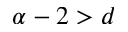Convert formula to latex. <formula><loc_0><loc_0><loc_500><loc_500>\alpha - 2 > d</formula> 